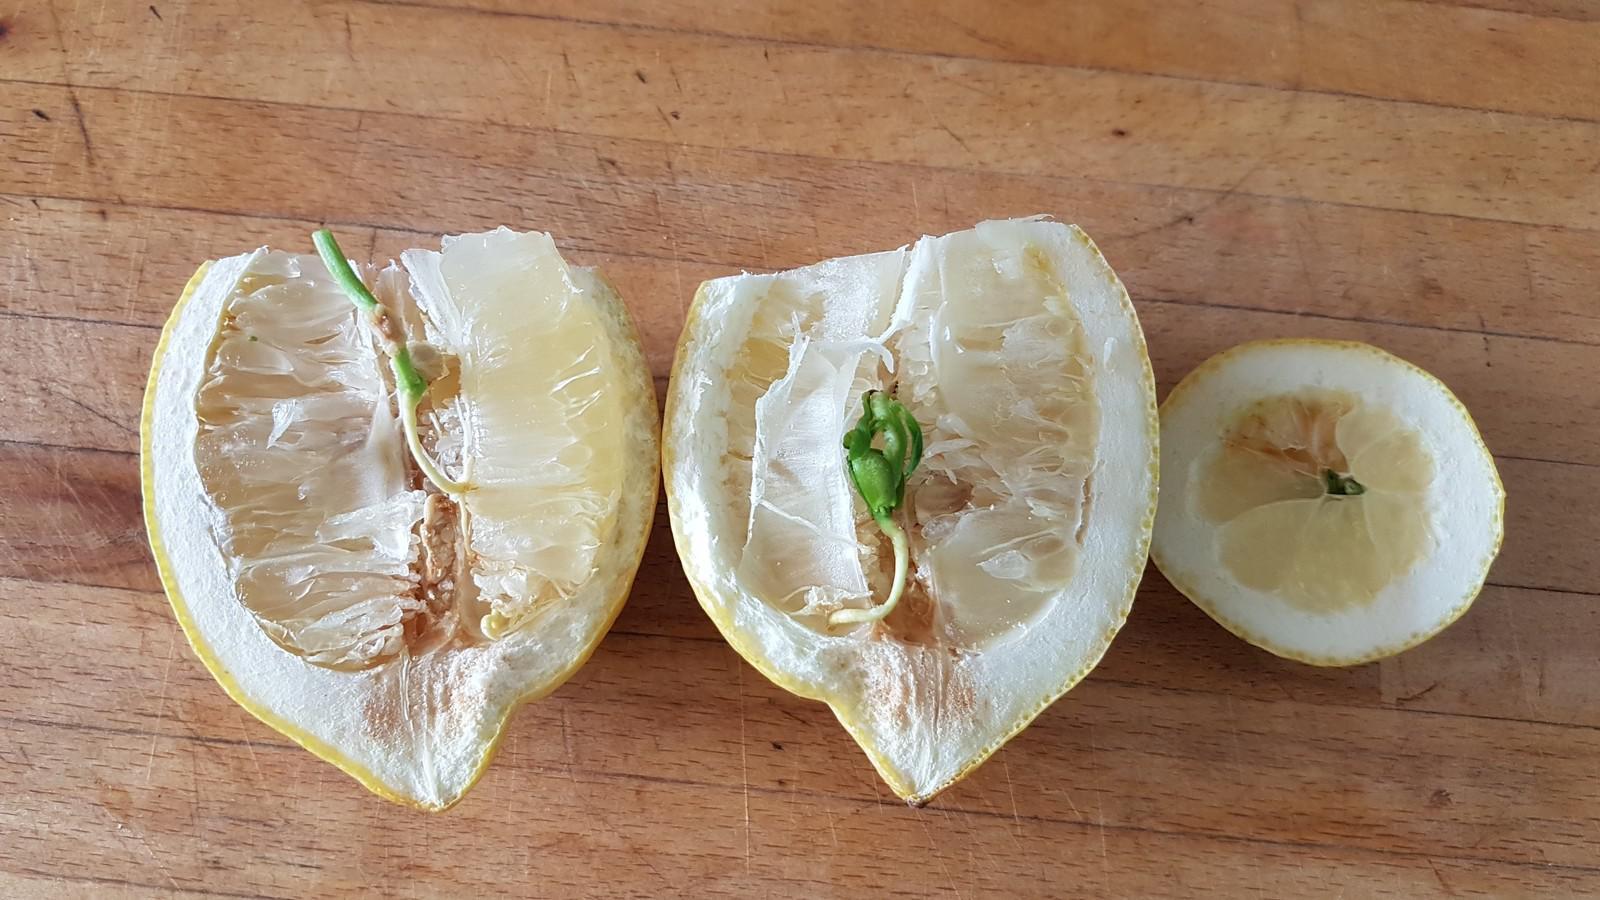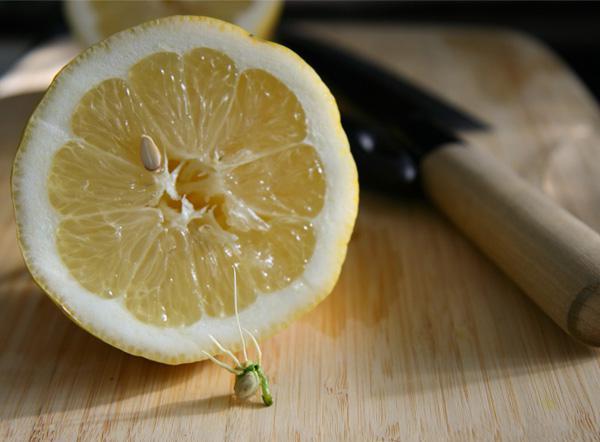The first image is the image on the left, the second image is the image on the right. Given the left and right images, does the statement "An image includes a knife beside a lemon cut in half on a wooden cutting surface." hold true? Answer yes or no. Yes. The first image is the image on the left, the second image is the image on the right. Examine the images to the left and right. Is the description "The left and right image contains a total of three lemons." accurate? Answer yes or no. No. 